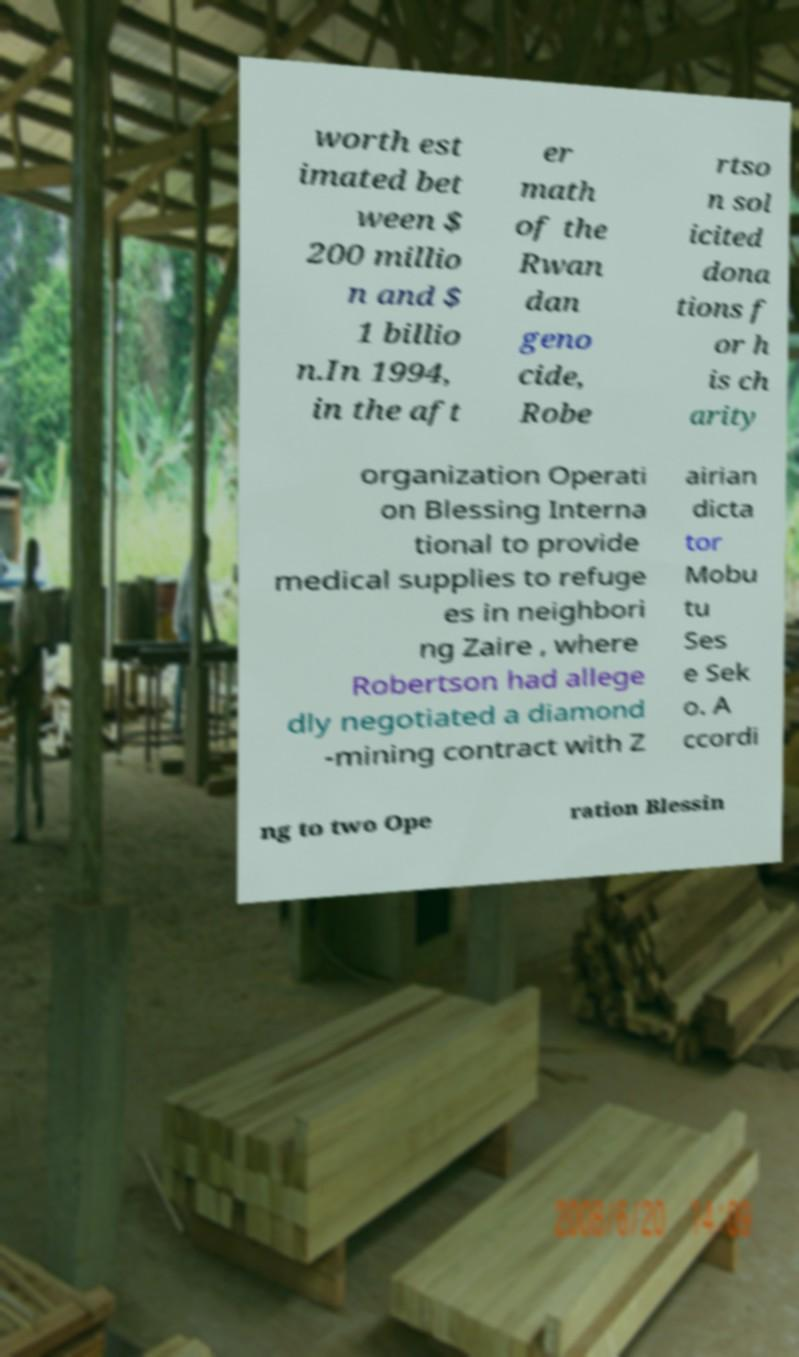There's text embedded in this image that I need extracted. Can you transcribe it verbatim? worth est imated bet ween $ 200 millio n and $ 1 billio n.In 1994, in the aft er math of the Rwan dan geno cide, Robe rtso n sol icited dona tions f or h is ch arity organization Operati on Blessing Interna tional to provide medical supplies to refuge es in neighbori ng Zaire , where Robertson had allege dly negotiated a diamond -mining contract with Z airian dicta tor Mobu tu Ses e Sek o. A ccordi ng to two Ope ration Blessin 